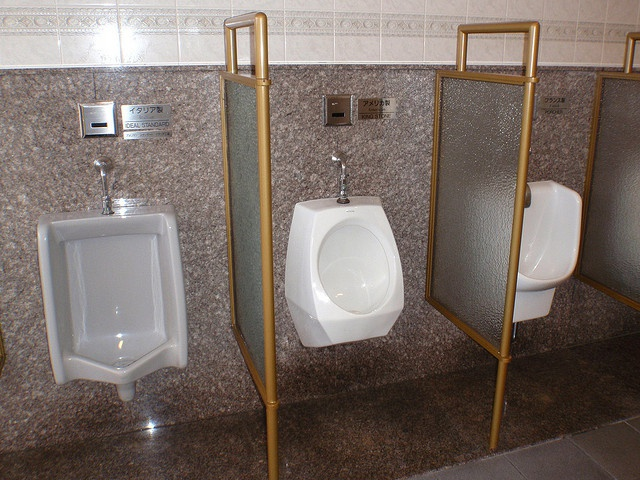Describe the objects in this image and their specific colors. I can see toilet in lightgray, darkgray, and gray tones, toilet in lightgray, darkgray, and gray tones, and toilet in lightgray and darkgray tones in this image. 